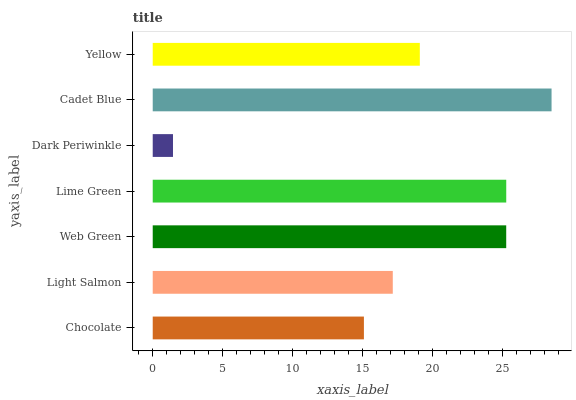Is Dark Periwinkle the minimum?
Answer yes or no. Yes. Is Cadet Blue the maximum?
Answer yes or no. Yes. Is Light Salmon the minimum?
Answer yes or no. No. Is Light Salmon the maximum?
Answer yes or no. No. Is Light Salmon greater than Chocolate?
Answer yes or no. Yes. Is Chocolate less than Light Salmon?
Answer yes or no. Yes. Is Chocolate greater than Light Salmon?
Answer yes or no. No. Is Light Salmon less than Chocolate?
Answer yes or no. No. Is Yellow the high median?
Answer yes or no. Yes. Is Yellow the low median?
Answer yes or no. Yes. Is Lime Green the high median?
Answer yes or no. No. Is Cadet Blue the low median?
Answer yes or no. No. 